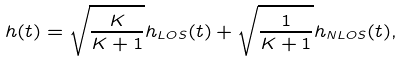Convert formula to latex. <formula><loc_0><loc_0><loc_500><loc_500>h ( t ) = \sqrt { \frac { K } { K + 1 } } h _ { L O S } ( t ) + \sqrt { \frac { 1 } { K + 1 } } h _ { N L O S } ( t ) ,</formula> 